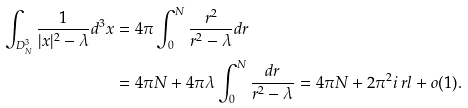<formula> <loc_0><loc_0><loc_500><loc_500>\int _ { D ^ { 3 } _ { N } } \frac { 1 } { | x | ^ { 2 } - \lambda } d ^ { 3 } x & = 4 \pi \int _ { 0 } ^ { N } \frac { r ^ { 2 } } { r ^ { 2 } - \lambda } d r \\ & = 4 \pi N + 4 \pi \lambda \int _ { 0 } ^ { N } \frac { d r } { r ^ { 2 } - \lambda } = 4 \pi N + 2 \pi ^ { 2 } i \ r l + o ( 1 ) .</formula> 